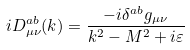<formula> <loc_0><loc_0><loc_500><loc_500>i D _ { \mu \nu } ^ { a b } ( k ) = \frac { - i \delta ^ { a b } g _ { \mu \nu } } { k ^ { 2 } - M ^ { 2 } + i \varepsilon }</formula> 